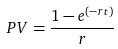<formula> <loc_0><loc_0><loc_500><loc_500>P V = \frac { 1 - e ^ { ( - r t ) } } { r }</formula> 